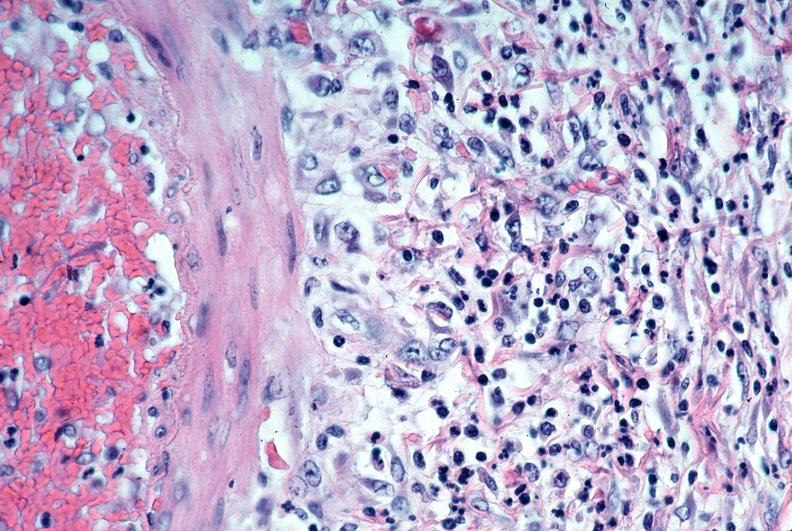s macerated stillborn present?
Answer the question using a single word or phrase. No 